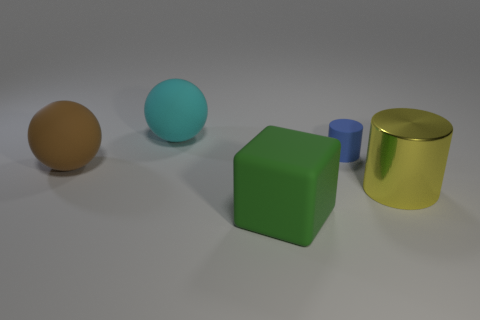Is there anything else that has the same size as the blue cylinder?
Your answer should be compact. No. Is there another object that has the same size as the brown object?
Your response must be concise. Yes. Is the shape of the tiny thing the same as the object right of the blue rubber object?
Provide a short and direct response. Yes. Is the size of the matte sphere in front of the tiny thing the same as the matte thing that is behind the blue cylinder?
Make the answer very short. Yes. How many other objects are the same shape as the yellow metal object?
Your answer should be compact. 1. What is the material of the cylinder that is in front of the small matte cylinder on the right side of the brown sphere?
Your answer should be very brief. Metal. What number of rubber objects are either small cylinders or tiny red things?
Provide a short and direct response. 1. Is there anything else that is the same material as the big yellow cylinder?
Give a very brief answer. No. There is a big matte object that is on the left side of the cyan matte thing; are there any large rubber spheres that are on the right side of it?
Offer a very short reply. Yes. What number of objects are cylinders that are behind the yellow shiny cylinder or large matte spheres on the right side of the big brown matte thing?
Ensure brevity in your answer.  2. 